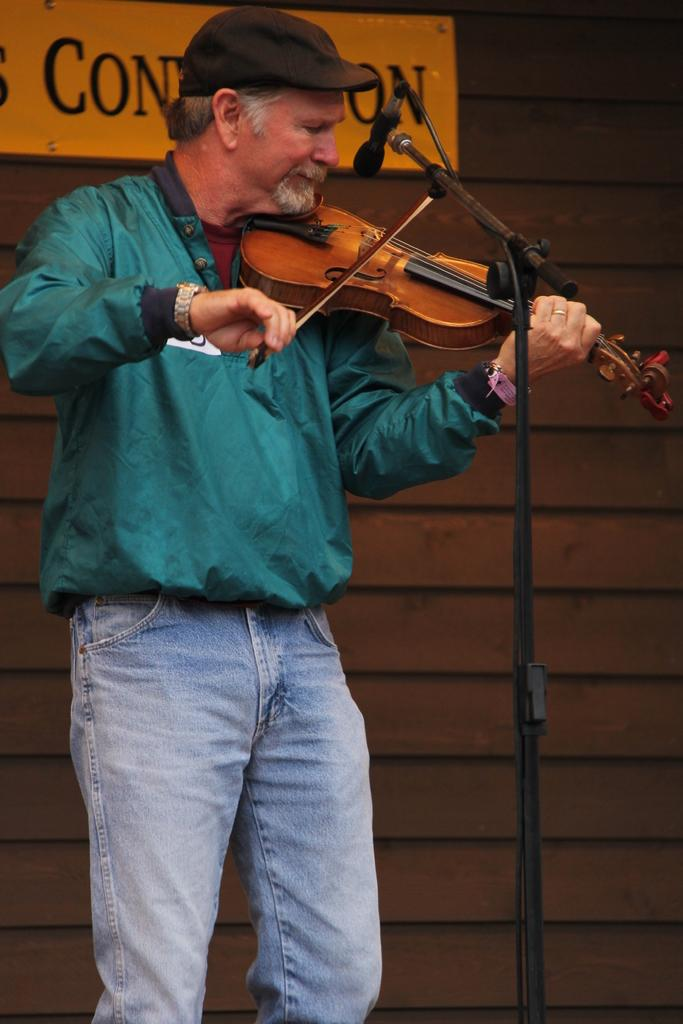What is the person on the left side of the image doing? The person is playing a violin. What is in front of the person in the image? There is a microphone in front of the person. What can be seen in the background of the image? There is a wooden wall in the background of the image. How many sacks are being carried by the pig in the image? There is no pig or sacks present in the image. What type of leg is visible on the person playing the violin? The image does not show any specific leg details of the person playing the violin. 